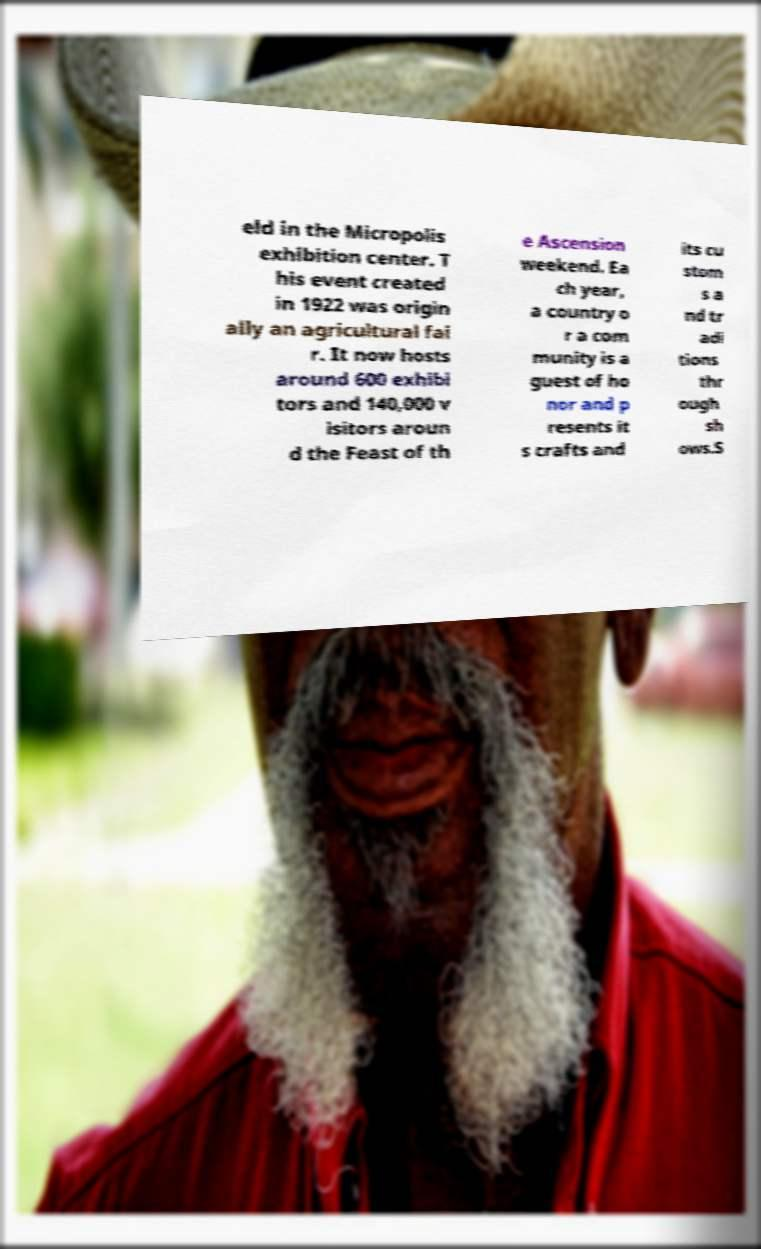Please identify and transcribe the text found in this image. eld in the Micropolis exhibition center. T his event created in 1922 was origin ally an agricultural fai r. It now hosts around 600 exhibi tors and 140,000 v isitors aroun d the Feast of th e Ascension weekend. Ea ch year, a country o r a com munity is a guest of ho nor and p resents it s crafts and its cu stom s a nd tr adi tions thr ough sh ows.S 